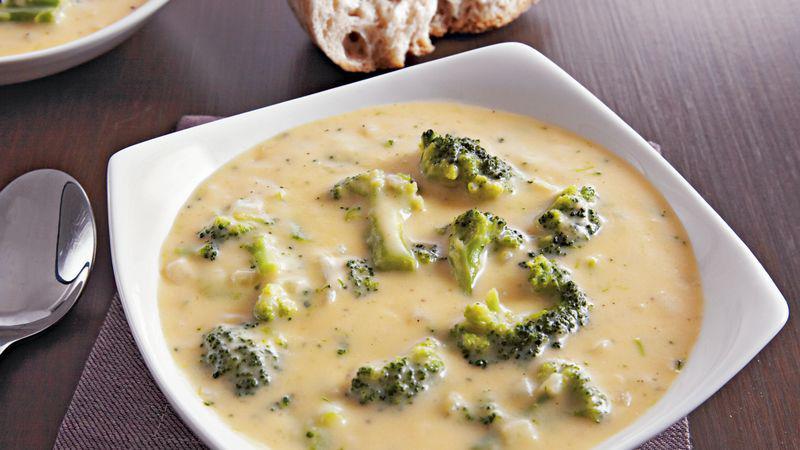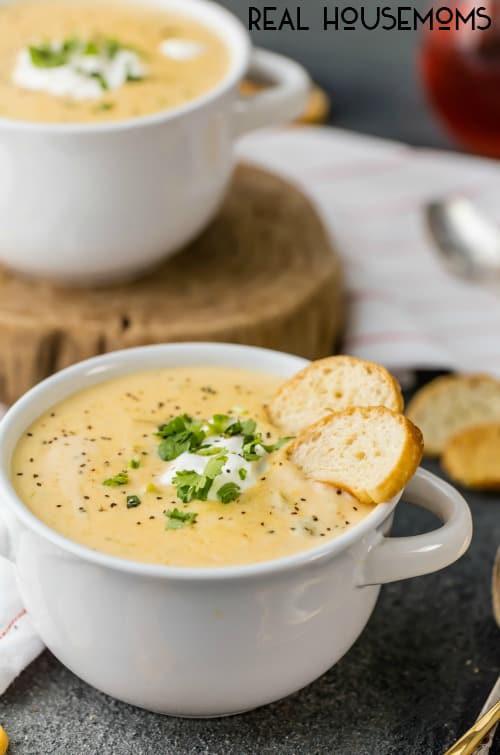The first image is the image on the left, the second image is the image on the right. Considering the images on both sides, is "The bwol of the spoon is visible in the image on the left" valid? Answer yes or no. Yes. 